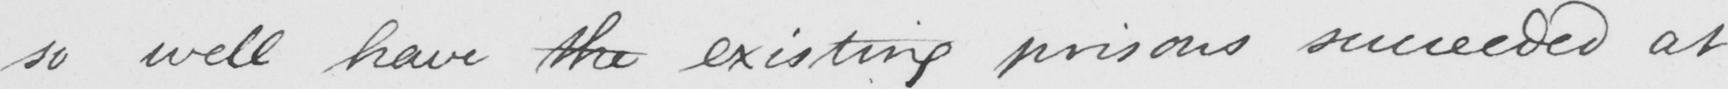Can you tell me what this handwritten text says? so well have the existing prisons succeeded at 